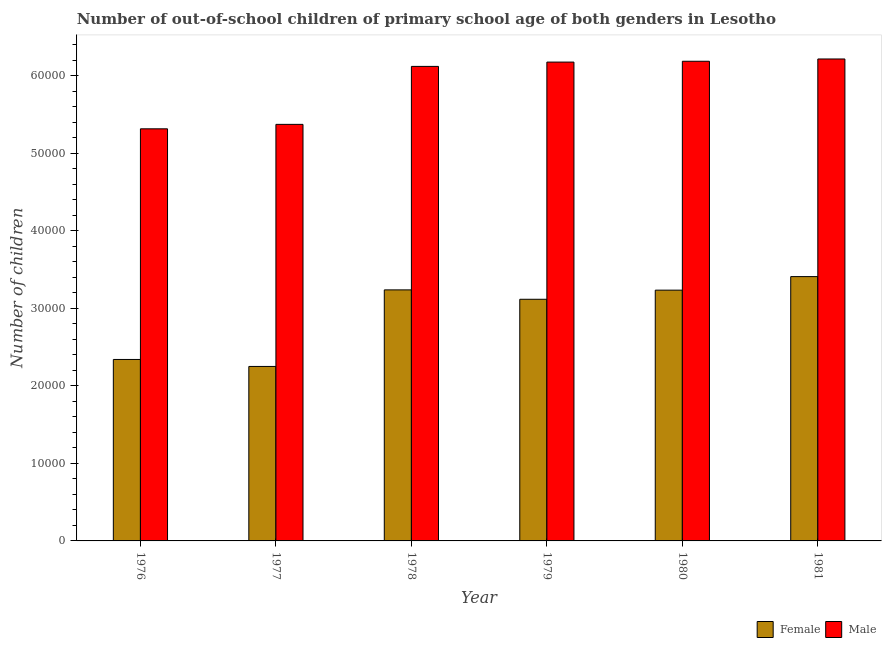How many different coloured bars are there?
Make the answer very short. 2. Are the number of bars per tick equal to the number of legend labels?
Your response must be concise. Yes. How many bars are there on the 4th tick from the right?
Your response must be concise. 2. What is the label of the 4th group of bars from the left?
Make the answer very short. 1979. In how many cases, is the number of bars for a given year not equal to the number of legend labels?
Offer a very short reply. 0. What is the number of male out-of-school students in 1980?
Provide a short and direct response. 6.18e+04. Across all years, what is the maximum number of male out-of-school students?
Your answer should be very brief. 6.21e+04. Across all years, what is the minimum number of female out-of-school students?
Provide a short and direct response. 2.25e+04. In which year was the number of male out-of-school students maximum?
Give a very brief answer. 1981. What is the total number of female out-of-school students in the graph?
Give a very brief answer. 1.76e+05. What is the difference between the number of female out-of-school students in 1980 and that in 1981?
Your answer should be very brief. -1746. What is the difference between the number of female out-of-school students in 1976 and the number of male out-of-school students in 1979?
Ensure brevity in your answer.  -7758. What is the average number of female out-of-school students per year?
Provide a succinct answer. 2.93e+04. In the year 1976, what is the difference between the number of male out-of-school students and number of female out-of-school students?
Offer a terse response. 0. What is the ratio of the number of male out-of-school students in 1976 to that in 1981?
Provide a succinct answer. 0.86. Is the difference between the number of male out-of-school students in 1977 and 1981 greater than the difference between the number of female out-of-school students in 1977 and 1981?
Give a very brief answer. No. What is the difference between the highest and the second highest number of male out-of-school students?
Offer a terse response. 294. What is the difference between the highest and the lowest number of male out-of-school students?
Offer a very short reply. 9004. In how many years, is the number of male out-of-school students greater than the average number of male out-of-school students taken over all years?
Offer a terse response. 4. What does the 2nd bar from the right in 1980 represents?
Your response must be concise. Female. How many bars are there?
Give a very brief answer. 12. How many years are there in the graph?
Your response must be concise. 6. Are the values on the major ticks of Y-axis written in scientific E-notation?
Make the answer very short. No. Does the graph contain any zero values?
Give a very brief answer. No. What is the title of the graph?
Provide a succinct answer. Number of out-of-school children of primary school age of both genders in Lesotho. Does "Stunting" appear as one of the legend labels in the graph?
Ensure brevity in your answer.  No. What is the label or title of the Y-axis?
Provide a succinct answer. Number of children. What is the Number of children in Female in 1976?
Offer a very short reply. 2.34e+04. What is the Number of children in Male in 1976?
Your answer should be very brief. 5.31e+04. What is the Number of children in Female in 1977?
Your answer should be very brief. 2.25e+04. What is the Number of children of Male in 1977?
Ensure brevity in your answer.  5.37e+04. What is the Number of children of Female in 1978?
Your answer should be very brief. 3.24e+04. What is the Number of children in Male in 1978?
Make the answer very short. 6.12e+04. What is the Number of children in Female in 1979?
Keep it short and to the point. 3.12e+04. What is the Number of children of Male in 1979?
Provide a succinct answer. 6.17e+04. What is the Number of children in Female in 1980?
Keep it short and to the point. 3.23e+04. What is the Number of children in Male in 1980?
Your answer should be very brief. 6.18e+04. What is the Number of children in Female in 1981?
Provide a succinct answer. 3.41e+04. What is the Number of children of Male in 1981?
Offer a very short reply. 6.21e+04. Across all years, what is the maximum Number of children in Female?
Offer a terse response. 3.41e+04. Across all years, what is the maximum Number of children in Male?
Make the answer very short. 6.21e+04. Across all years, what is the minimum Number of children of Female?
Your response must be concise. 2.25e+04. Across all years, what is the minimum Number of children in Male?
Give a very brief answer. 5.31e+04. What is the total Number of children of Female in the graph?
Offer a terse response. 1.76e+05. What is the total Number of children in Male in the graph?
Your answer should be very brief. 3.54e+05. What is the difference between the Number of children of Female in 1976 and that in 1977?
Your answer should be compact. 902. What is the difference between the Number of children of Male in 1976 and that in 1977?
Provide a short and direct response. -573. What is the difference between the Number of children of Female in 1976 and that in 1978?
Your answer should be very brief. -8969. What is the difference between the Number of children in Male in 1976 and that in 1978?
Provide a short and direct response. -8047. What is the difference between the Number of children in Female in 1976 and that in 1979?
Provide a short and direct response. -7758. What is the difference between the Number of children of Male in 1976 and that in 1979?
Provide a short and direct response. -8602. What is the difference between the Number of children in Female in 1976 and that in 1980?
Make the answer very short. -8935. What is the difference between the Number of children of Male in 1976 and that in 1980?
Provide a succinct answer. -8710. What is the difference between the Number of children of Female in 1976 and that in 1981?
Provide a succinct answer. -1.07e+04. What is the difference between the Number of children in Male in 1976 and that in 1981?
Give a very brief answer. -9004. What is the difference between the Number of children in Female in 1977 and that in 1978?
Offer a very short reply. -9871. What is the difference between the Number of children in Male in 1977 and that in 1978?
Offer a terse response. -7474. What is the difference between the Number of children in Female in 1977 and that in 1979?
Your response must be concise. -8660. What is the difference between the Number of children of Male in 1977 and that in 1979?
Give a very brief answer. -8029. What is the difference between the Number of children in Female in 1977 and that in 1980?
Provide a succinct answer. -9837. What is the difference between the Number of children of Male in 1977 and that in 1980?
Your response must be concise. -8137. What is the difference between the Number of children in Female in 1977 and that in 1981?
Provide a succinct answer. -1.16e+04. What is the difference between the Number of children of Male in 1977 and that in 1981?
Offer a terse response. -8431. What is the difference between the Number of children of Female in 1978 and that in 1979?
Make the answer very short. 1211. What is the difference between the Number of children in Male in 1978 and that in 1979?
Your response must be concise. -555. What is the difference between the Number of children of Female in 1978 and that in 1980?
Your answer should be very brief. 34. What is the difference between the Number of children in Male in 1978 and that in 1980?
Your answer should be compact. -663. What is the difference between the Number of children of Female in 1978 and that in 1981?
Make the answer very short. -1712. What is the difference between the Number of children in Male in 1978 and that in 1981?
Provide a short and direct response. -957. What is the difference between the Number of children of Female in 1979 and that in 1980?
Provide a succinct answer. -1177. What is the difference between the Number of children in Male in 1979 and that in 1980?
Your answer should be very brief. -108. What is the difference between the Number of children of Female in 1979 and that in 1981?
Make the answer very short. -2923. What is the difference between the Number of children of Male in 1979 and that in 1981?
Your response must be concise. -402. What is the difference between the Number of children in Female in 1980 and that in 1981?
Keep it short and to the point. -1746. What is the difference between the Number of children of Male in 1980 and that in 1981?
Provide a short and direct response. -294. What is the difference between the Number of children of Female in 1976 and the Number of children of Male in 1977?
Make the answer very short. -3.03e+04. What is the difference between the Number of children of Female in 1976 and the Number of children of Male in 1978?
Your response must be concise. -3.78e+04. What is the difference between the Number of children in Female in 1976 and the Number of children in Male in 1979?
Provide a short and direct response. -3.83e+04. What is the difference between the Number of children of Female in 1976 and the Number of children of Male in 1980?
Offer a terse response. -3.84e+04. What is the difference between the Number of children in Female in 1976 and the Number of children in Male in 1981?
Offer a very short reply. -3.87e+04. What is the difference between the Number of children in Female in 1977 and the Number of children in Male in 1978?
Keep it short and to the point. -3.87e+04. What is the difference between the Number of children of Female in 1977 and the Number of children of Male in 1979?
Provide a succinct answer. -3.92e+04. What is the difference between the Number of children of Female in 1977 and the Number of children of Male in 1980?
Provide a short and direct response. -3.93e+04. What is the difference between the Number of children in Female in 1977 and the Number of children in Male in 1981?
Provide a succinct answer. -3.96e+04. What is the difference between the Number of children of Female in 1978 and the Number of children of Male in 1979?
Your answer should be compact. -2.94e+04. What is the difference between the Number of children in Female in 1978 and the Number of children in Male in 1980?
Offer a very short reply. -2.95e+04. What is the difference between the Number of children of Female in 1978 and the Number of children of Male in 1981?
Your response must be concise. -2.98e+04. What is the difference between the Number of children of Female in 1979 and the Number of children of Male in 1980?
Provide a succinct answer. -3.07e+04. What is the difference between the Number of children of Female in 1979 and the Number of children of Male in 1981?
Offer a terse response. -3.10e+04. What is the difference between the Number of children in Female in 1980 and the Number of children in Male in 1981?
Offer a very short reply. -2.98e+04. What is the average Number of children in Female per year?
Provide a short and direct response. 2.93e+04. What is the average Number of children of Male per year?
Your answer should be compact. 5.90e+04. In the year 1976, what is the difference between the Number of children of Female and Number of children of Male?
Give a very brief answer. -2.97e+04. In the year 1977, what is the difference between the Number of children of Female and Number of children of Male?
Provide a succinct answer. -3.12e+04. In the year 1978, what is the difference between the Number of children of Female and Number of children of Male?
Your response must be concise. -2.88e+04. In the year 1979, what is the difference between the Number of children of Female and Number of children of Male?
Your response must be concise. -3.06e+04. In the year 1980, what is the difference between the Number of children of Female and Number of children of Male?
Ensure brevity in your answer.  -2.95e+04. In the year 1981, what is the difference between the Number of children of Female and Number of children of Male?
Make the answer very short. -2.81e+04. What is the ratio of the Number of children in Female in 1976 to that in 1977?
Give a very brief answer. 1.04. What is the ratio of the Number of children of Male in 1976 to that in 1977?
Keep it short and to the point. 0.99. What is the ratio of the Number of children in Female in 1976 to that in 1978?
Offer a very short reply. 0.72. What is the ratio of the Number of children in Male in 1976 to that in 1978?
Keep it short and to the point. 0.87. What is the ratio of the Number of children of Female in 1976 to that in 1979?
Your response must be concise. 0.75. What is the ratio of the Number of children of Male in 1976 to that in 1979?
Make the answer very short. 0.86. What is the ratio of the Number of children in Female in 1976 to that in 1980?
Make the answer very short. 0.72. What is the ratio of the Number of children in Male in 1976 to that in 1980?
Your answer should be compact. 0.86. What is the ratio of the Number of children of Female in 1976 to that in 1981?
Provide a succinct answer. 0.69. What is the ratio of the Number of children in Male in 1976 to that in 1981?
Provide a short and direct response. 0.86. What is the ratio of the Number of children of Female in 1977 to that in 1978?
Offer a very short reply. 0.69. What is the ratio of the Number of children in Male in 1977 to that in 1978?
Provide a short and direct response. 0.88. What is the ratio of the Number of children in Female in 1977 to that in 1979?
Your response must be concise. 0.72. What is the ratio of the Number of children of Male in 1977 to that in 1979?
Make the answer very short. 0.87. What is the ratio of the Number of children of Female in 1977 to that in 1980?
Provide a short and direct response. 0.7. What is the ratio of the Number of children of Male in 1977 to that in 1980?
Offer a very short reply. 0.87. What is the ratio of the Number of children of Female in 1977 to that in 1981?
Your answer should be very brief. 0.66. What is the ratio of the Number of children of Male in 1977 to that in 1981?
Your response must be concise. 0.86. What is the ratio of the Number of children of Female in 1978 to that in 1979?
Keep it short and to the point. 1.04. What is the ratio of the Number of children in Male in 1978 to that in 1979?
Offer a very short reply. 0.99. What is the ratio of the Number of children of Male in 1978 to that in 1980?
Provide a short and direct response. 0.99. What is the ratio of the Number of children in Female in 1978 to that in 1981?
Keep it short and to the point. 0.95. What is the ratio of the Number of children of Male in 1978 to that in 1981?
Provide a short and direct response. 0.98. What is the ratio of the Number of children in Female in 1979 to that in 1980?
Your answer should be compact. 0.96. What is the ratio of the Number of children in Female in 1979 to that in 1981?
Provide a short and direct response. 0.91. What is the ratio of the Number of children in Male in 1979 to that in 1981?
Give a very brief answer. 0.99. What is the ratio of the Number of children in Female in 1980 to that in 1981?
Give a very brief answer. 0.95. What is the ratio of the Number of children of Male in 1980 to that in 1981?
Ensure brevity in your answer.  1. What is the difference between the highest and the second highest Number of children of Female?
Make the answer very short. 1712. What is the difference between the highest and the second highest Number of children in Male?
Give a very brief answer. 294. What is the difference between the highest and the lowest Number of children of Female?
Your answer should be very brief. 1.16e+04. What is the difference between the highest and the lowest Number of children in Male?
Ensure brevity in your answer.  9004. 